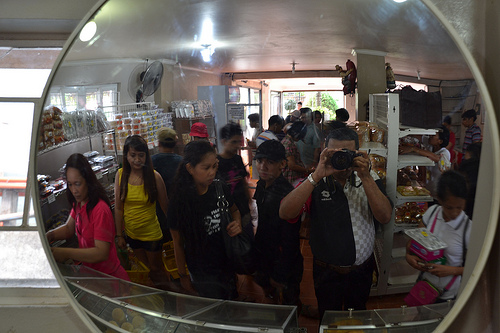<image>
Is there a person behind the person? Yes. From this viewpoint, the person is positioned behind the person, with the person partially or fully occluding the person. 